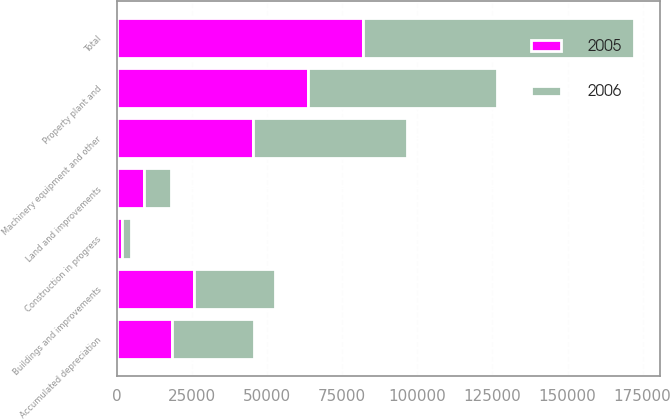Convert chart to OTSL. <chart><loc_0><loc_0><loc_500><loc_500><stacked_bar_chart><ecel><fcel>Land and improvements<fcel>Buildings and improvements<fcel>Machinery equipment and other<fcel>Construction in progress<fcel>Total<fcel>Accumulated depreciation<fcel>Property plant and<nl><fcel>2006<fcel>9055<fcel>26967<fcel>51298<fcel>2809<fcel>90129<fcel>27278<fcel>62851<nl><fcel>2005<fcel>9055<fcel>25666<fcel>45283<fcel>1891<fcel>81895<fcel>18271<fcel>63624<nl></chart> 